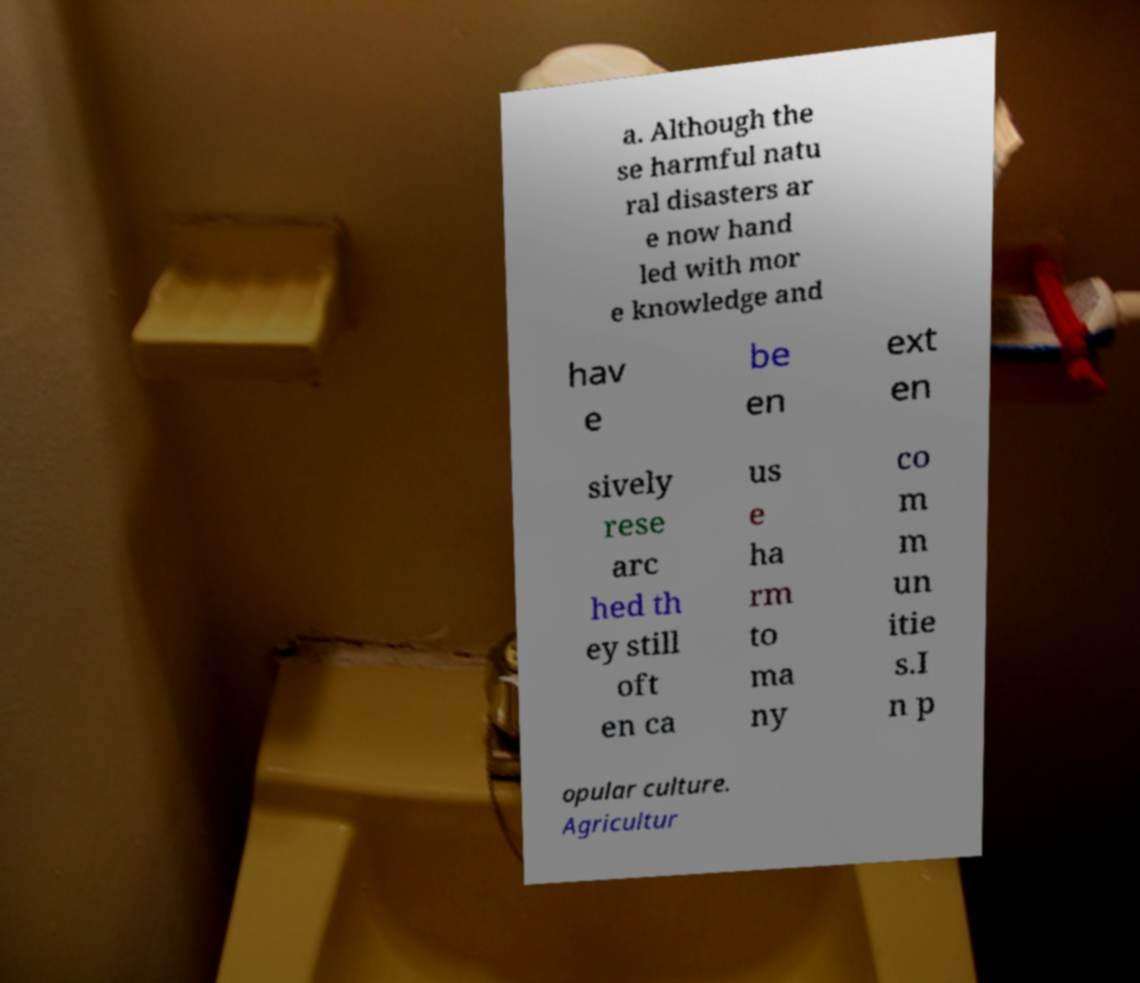What messages or text are displayed in this image? I need them in a readable, typed format. a. Although the se harmful natu ral disasters ar e now hand led with mor e knowledge and hav e be en ext en sively rese arc hed th ey still oft en ca us e ha rm to ma ny co m m un itie s.I n p opular culture. Agricultur 